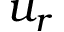Convert formula to latex. <formula><loc_0><loc_0><loc_500><loc_500>u _ { r }</formula> 